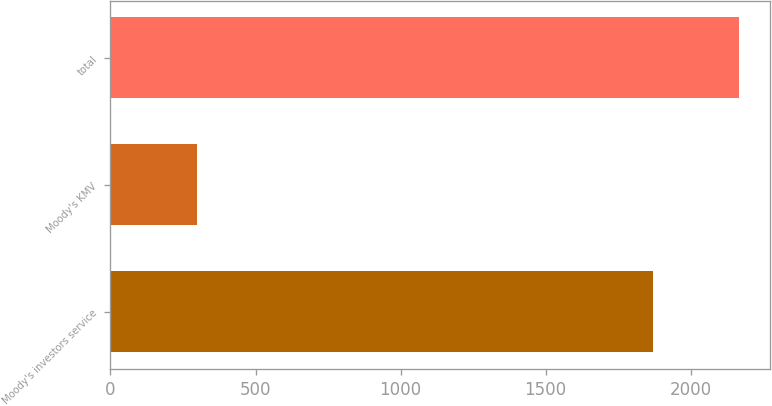Convert chart to OTSL. <chart><loc_0><loc_0><loc_500><loc_500><bar_chart><fcel>Moody's investors service<fcel>Moody's KMV<fcel>total<nl><fcel>1869<fcel>297<fcel>2166<nl></chart> 